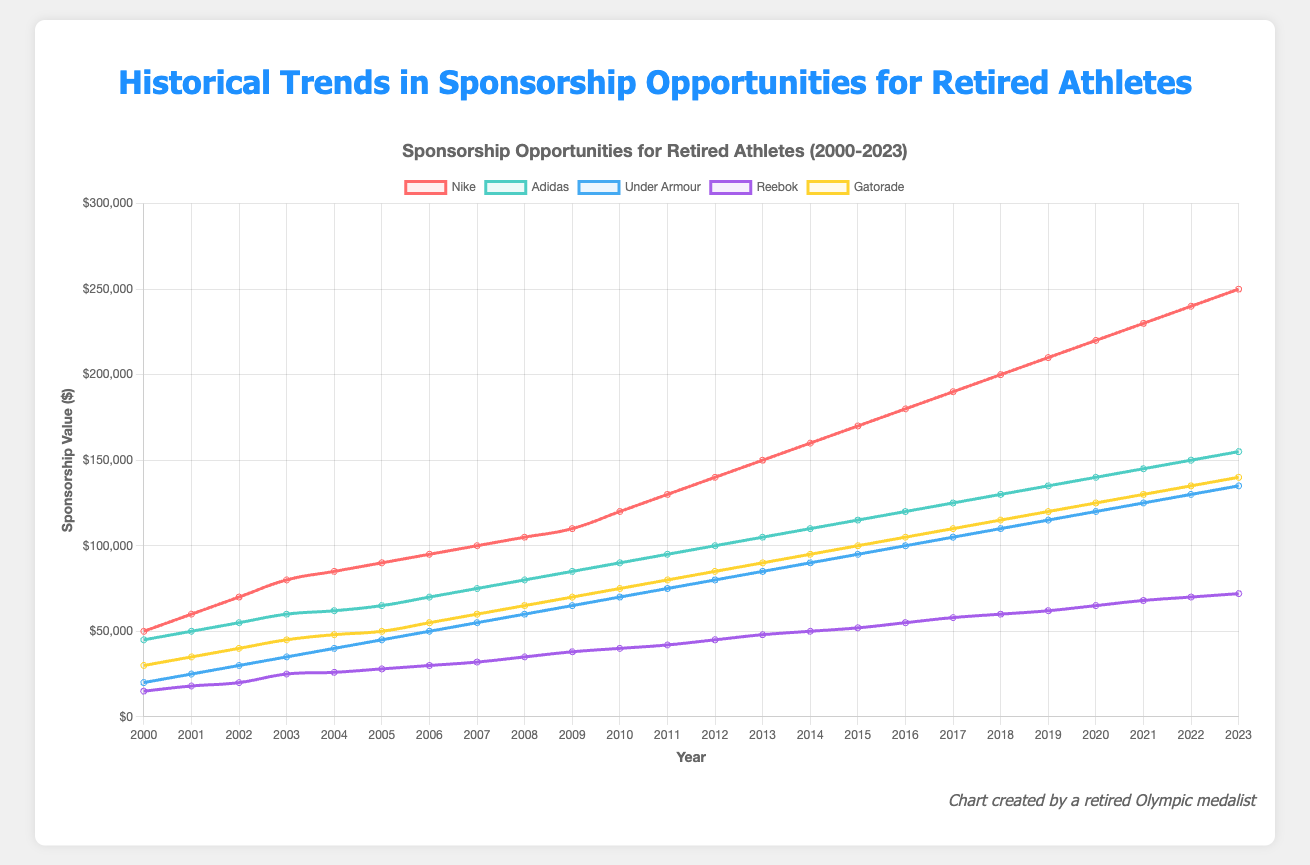What is the trend for sponsorship opportunities from Nike between 2000 and 2023? By analyzing the graph, you can see that the sponsorship opportunities from Nike are represented by a red line. The trend shows a consistent increase in the value of sponsorships from $50,000 in 2000 to $250,000 in 2023.
Answer: Consistent increase Between Nike and Adidas, which company saw the highest sponsorship value in 2023? In 2023, the chart shows that the Nike sponsorship value is at the highest value represented by a red line at $250,000 compared to the blue line representing Adidas at $155,000.
Answer: Nike Which company had the least sponsorship value in 2000 and how much was it? In 2000, the purple line representing Reebok had the least sponsorship value with a sponsorship amount of $15,000, as seen on the chart.
Answer: Reebok, $15,000 By how much did sponsorship opportunities from Under Armour increase between 2005 and 2015? Under Armour's value in 2005 was $45,000, and by 2015 the value increased to $95,000. The increase is $95,000 - $45,000 = $50,000.
Answer: $50,000 Which company shows the steepest rise in sponsorship opportunities between 2010 and 2020? By examining the slopes of the lines on the chart, Nike shows the steepest rise, going from $120,000 in 2010 to $220,000 in 2020, an increase of $100,000 over 10 years.
Answer: Nike Identify the year where all companies show an increase in sponsorship opportunities from the previous year. By observing yearly changes, all companies show an increase in sponsorship opportunities from 2011 to 2012. Each line shows an upward movement.
Answer: 2012 What is the average sponsorship value for Gatorade from 2000 to 2023? To calculate this, sum all the annual Gatorade sponsorship values from the chart (30000 + 35000 + ... + 140000) which totals $2,825,000, and divide by the number of years, 24. The average is $2,825,000 / 24 = $117,708.33.
Answer: $117,708.33 How does the sponsorship value for Reebok in 2023 compare to its value in 2003? In 2023, Reebok's value is $72,000, and in 2003, it was $25,000. Comparing the two values shows an increase of $72,000 - $25,000 = $47,000.
Answer: Increased by $47,000 Between 2000 and 2023, which company's sponsorship values remained the most linear and consistent? Observing the graph, Adidas shows a steady and linear increase in sponsorship values without any sharp changes or deviations.
Answer: Adidas What was the difference in sponsorship opportunities between the highest and lowest values in 2010? In 2010, Nike had the highest value at $120,000 and Reebok had the lowest at $40,000. The difference is $120,000 - $40,000 = $80,000.
Answer: $80,000 